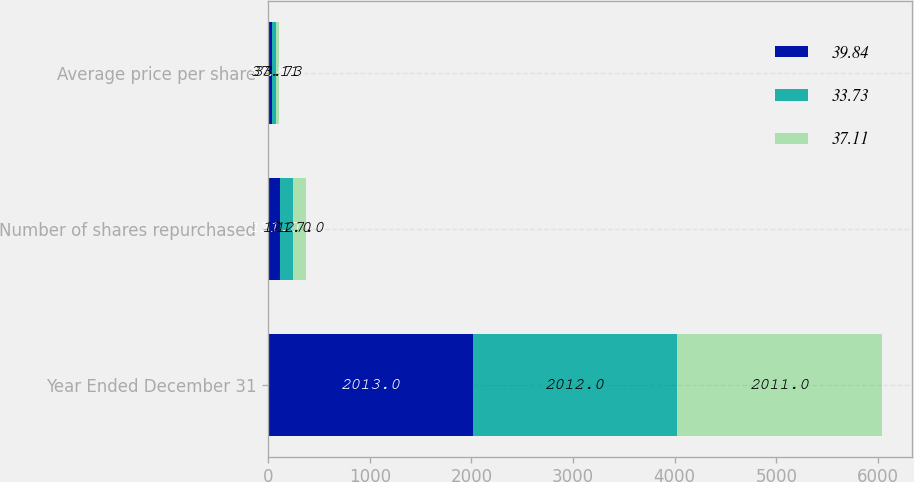Convert chart to OTSL. <chart><loc_0><loc_0><loc_500><loc_500><stacked_bar_chart><ecel><fcel>Year Ended December 31<fcel>Number of shares repurchased<fcel>Average price per share<nl><fcel>39.84<fcel>2013<fcel>121<fcel>39.84<nl><fcel>33.73<fcel>2012<fcel>121<fcel>37.11<nl><fcel>37.11<fcel>2011<fcel>127<fcel>33.73<nl></chart> 